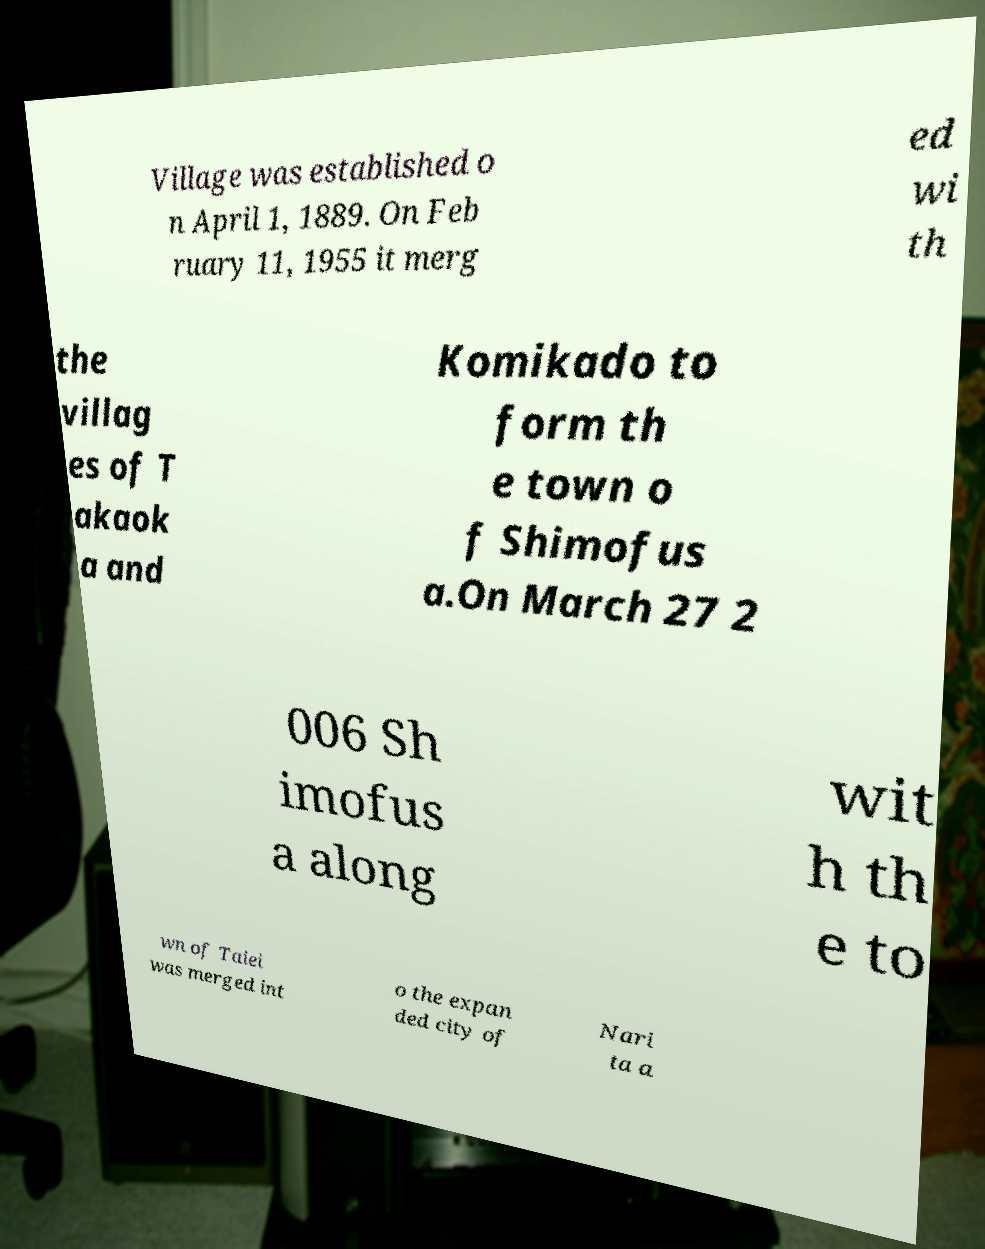For documentation purposes, I need the text within this image transcribed. Could you provide that? Village was established o n April 1, 1889. On Feb ruary 11, 1955 it merg ed wi th the villag es of T akaok a and Komikado to form th e town o f Shimofus a.On March 27 2 006 Sh imofus a along wit h th e to wn of Taiei was merged int o the expan ded city of Nari ta a 